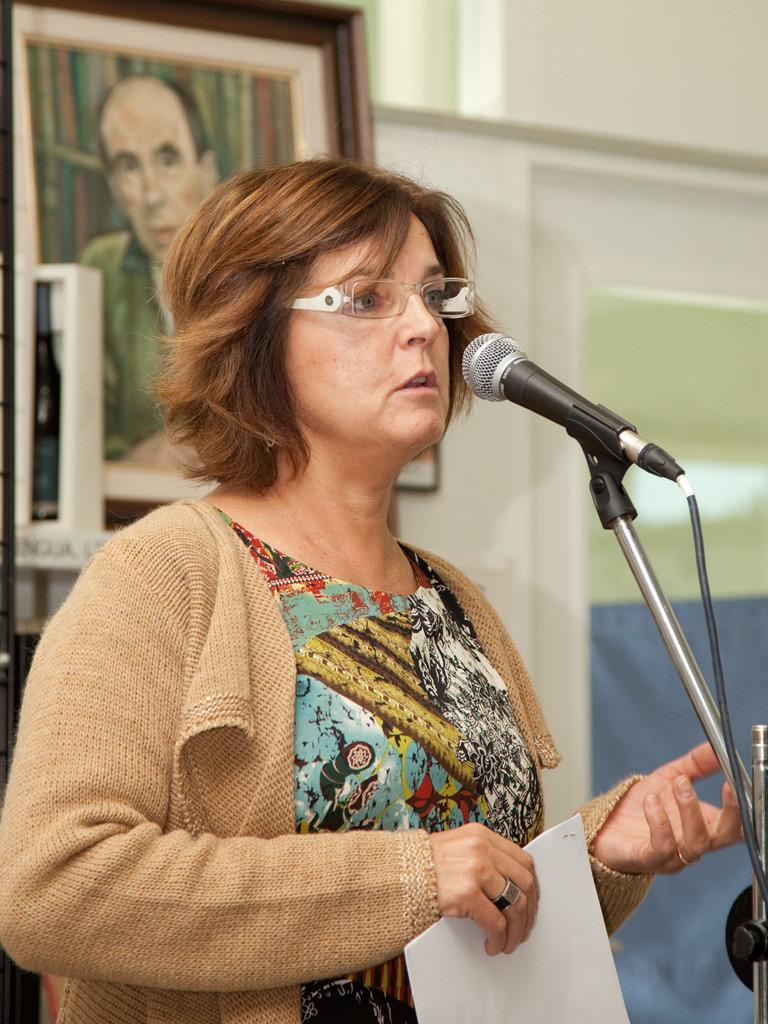What is the person in the image doing? The person is standing and talking. What is the person holding in the image? The person is holding a paper. What accessory is the person wearing? The person is wearing glasses. What object is present for amplifying the person's voice? There is a microphone with a stand in the image. What can be seen in the background of the image? There is a wall and a frame in the background. How many sisters are standing next to the person in the image? There are no sisters present in the image; only one person is visible. What type of leaf can be seen falling from the frame in the background? There is no leaf present in the image, and the frame is not depicted as having any leaves. 